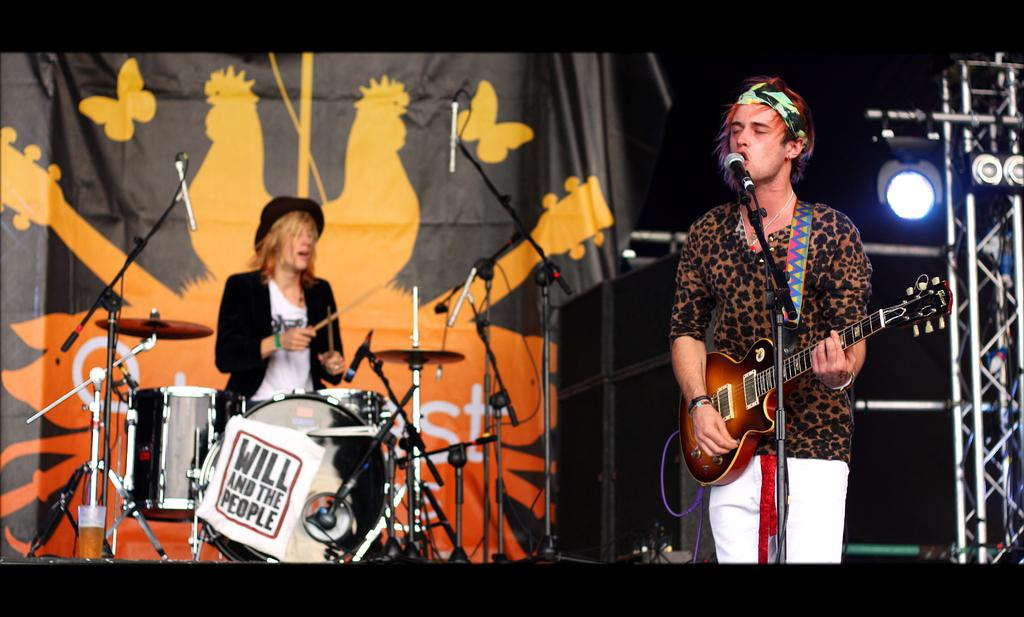How many people are in the image? There are two people in the image. What are the people doing in the image? One person is standing in front of a mic and playing a guitar, while another person is playing a drum set. What type of slope can be seen in the background of the image? There is no slope visible in the background of the image. What year is depicted in the image? The image does not depict a specific year; it is a snapshot of a musical performance. 